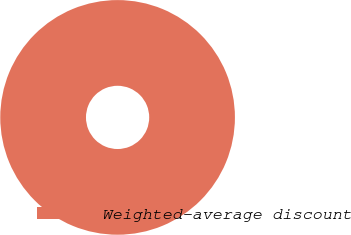Convert chart to OTSL. <chart><loc_0><loc_0><loc_500><loc_500><pie_chart><fcel>Weighted-average discount<nl><fcel>100.0%<nl></chart> 